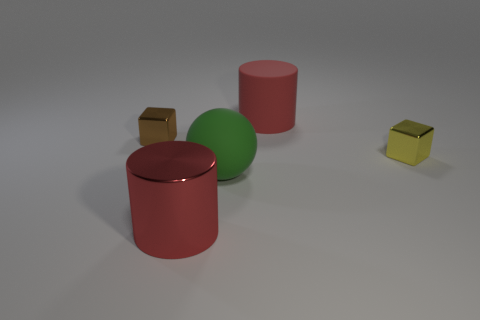Add 2 yellow blocks. How many objects exist? 7 Subtract all big green matte objects. Subtract all big red cylinders. How many objects are left? 2 Add 2 red metallic cylinders. How many red metallic cylinders are left? 3 Add 5 big balls. How many big balls exist? 6 Subtract 0 gray cubes. How many objects are left? 5 Subtract all cylinders. How many objects are left? 3 Subtract all blue cylinders. Subtract all cyan cubes. How many cylinders are left? 2 